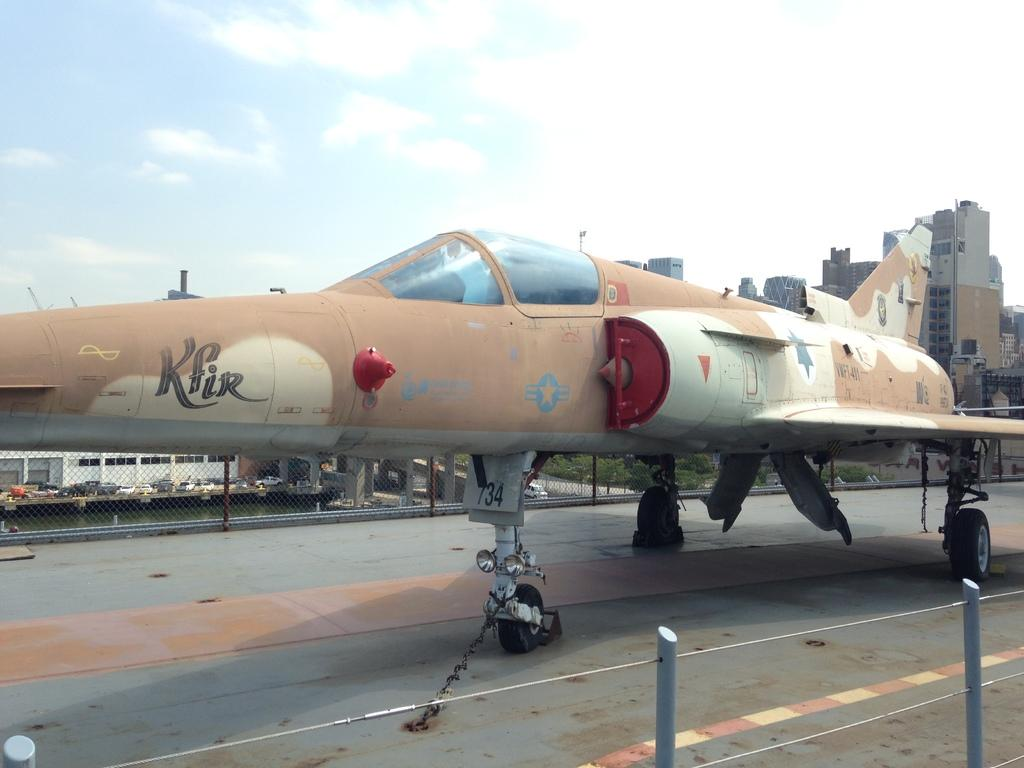Provide a one-sentence caption for the provided image. a camo Kfir plane is chained to the deck of the area it sits. 